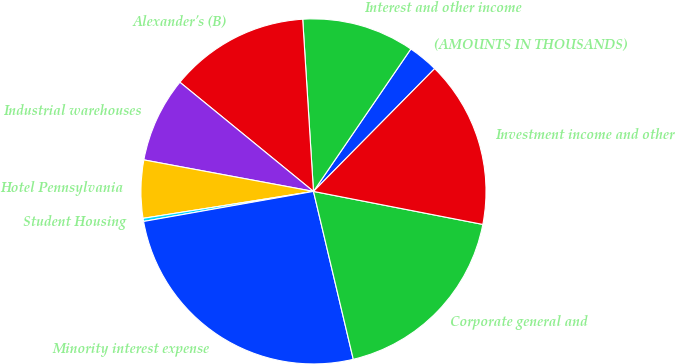Convert chart. <chart><loc_0><loc_0><loc_500><loc_500><pie_chart><fcel>(AMOUNTS IN THOUSANDS)<fcel>Interest and other income<fcel>Alexander's (B)<fcel>Industrial warehouses<fcel>Hotel Pennsylvania<fcel>Student Housing<fcel>Minority interest expense<fcel>Corporate general and<fcel>Investment income and other<nl><fcel>2.85%<fcel>10.54%<fcel>13.1%<fcel>7.98%<fcel>5.42%<fcel>0.29%<fcel>25.92%<fcel>18.23%<fcel>15.67%<nl></chart> 